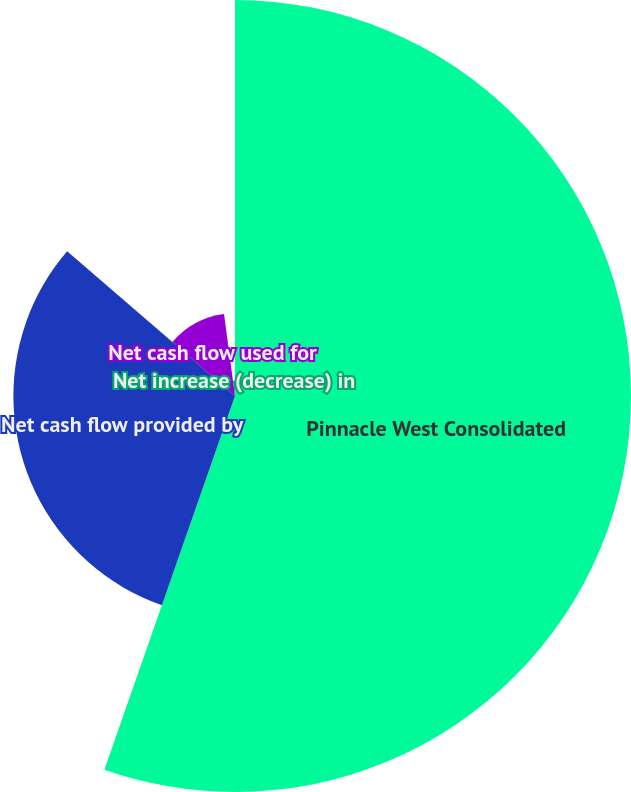<chart> <loc_0><loc_0><loc_500><loc_500><pie_chart><fcel>Pinnacle West Consolidated<fcel>Net cash flow provided by<fcel>Net cash flow used for<fcel>Net increase (decrease) in<nl><fcel>55.35%<fcel>30.97%<fcel>11.56%<fcel>2.12%<nl></chart> 